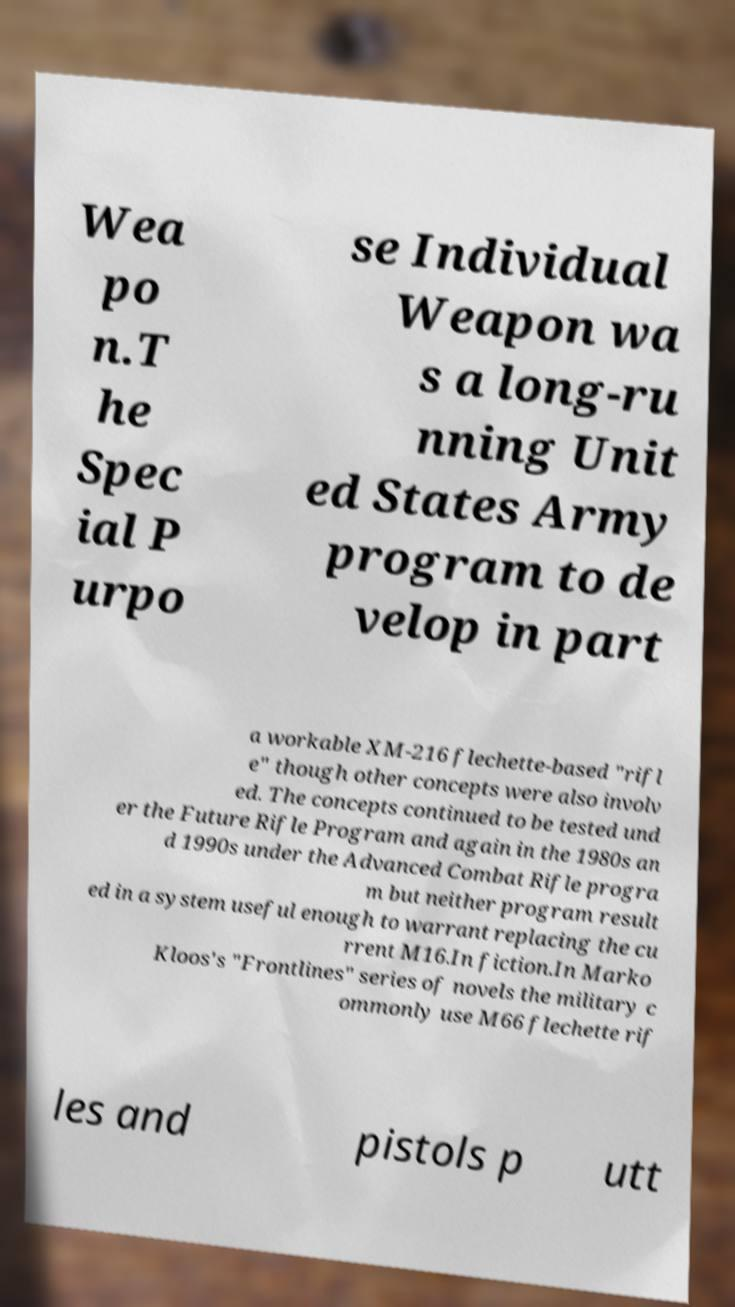Please read and relay the text visible in this image. What does it say? Wea po n.T he Spec ial P urpo se Individual Weapon wa s a long-ru nning Unit ed States Army program to de velop in part a workable XM-216 flechette-based "rifl e" though other concepts were also involv ed. The concepts continued to be tested und er the Future Rifle Program and again in the 1980s an d 1990s under the Advanced Combat Rifle progra m but neither program result ed in a system useful enough to warrant replacing the cu rrent M16.In fiction.In Marko Kloos's "Frontlines" series of novels the military c ommonly use M66 flechette rif les and pistols p utt 